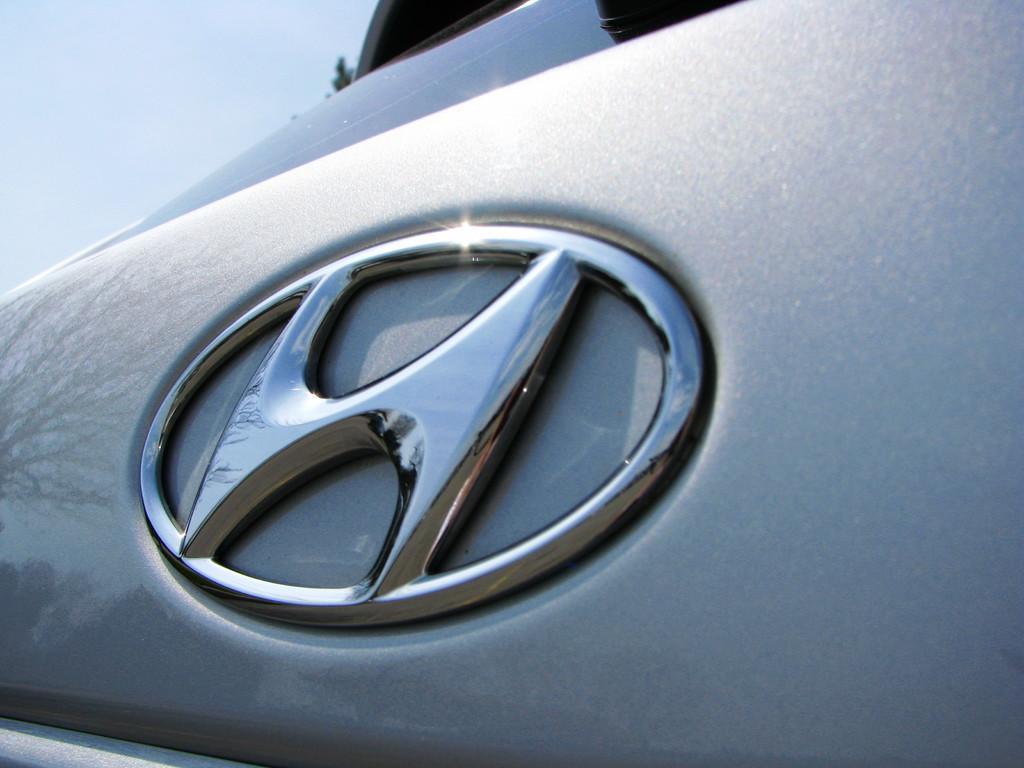Could you give a brief overview of what you see in this image? This is a picture of a car. Sky is clear and it is sunny. On the left we can see the reflection of a tree on the car. 